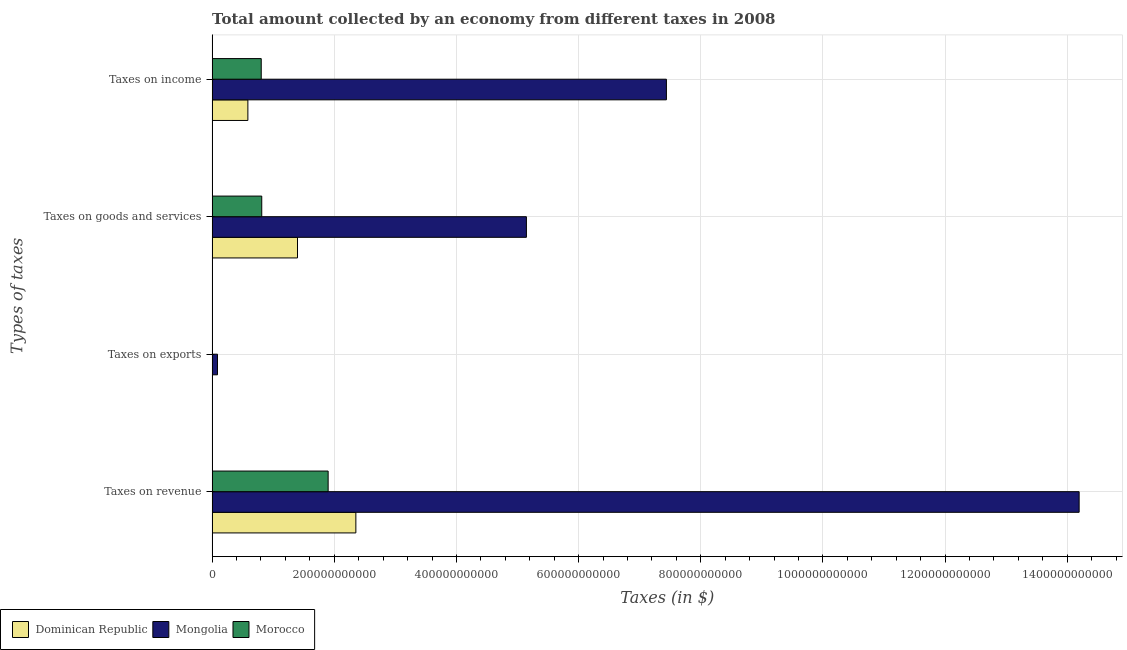How many different coloured bars are there?
Your response must be concise. 3. How many groups of bars are there?
Make the answer very short. 4. Are the number of bars per tick equal to the number of legend labels?
Your response must be concise. Yes. Are the number of bars on each tick of the Y-axis equal?
Offer a terse response. Yes. How many bars are there on the 2nd tick from the top?
Keep it short and to the point. 3. How many bars are there on the 3rd tick from the bottom?
Offer a terse response. 3. What is the label of the 2nd group of bars from the top?
Give a very brief answer. Taxes on goods and services. What is the amount collected as tax on exports in Mongolia?
Your answer should be very brief. 8.78e+09. Across all countries, what is the maximum amount collected as tax on exports?
Provide a short and direct response. 8.78e+09. Across all countries, what is the minimum amount collected as tax on goods?
Provide a succinct answer. 8.12e+1. In which country was the amount collected as tax on income maximum?
Offer a very short reply. Mongolia. In which country was the amount collected as tax on goods minimum?
Provide a short and direct response. Morocco. What is the total amount collected as tax on revenue in the graph?
Your response must be concise. 1.84e+12. What is the difference between the amount collected as tax on revenue in Dominican Republic and that in Mongolia?
Give a very brief answer. -1.18e+12. What is the difference between the amount collected as tax on revenue in Dominican Republic and the amount collected as tax on income in Mongolia?
Make the answer very short. -5.08e+11. What is the average amount collected as tax on exports per country?
Provide a short and direct response. 2.99e+09. What is the difference between the amount collected as tax on goods and amount collected as tax on exports in Mongolia?
Offer a terse response. 5.06e+11. In how many countries, is the amount collected as tax on income greater than 1120000000000 $?
Keep it short and to the point. 0. What is the ratio of the amount collected as tax on exports in Morocco to that in Dominican Republic?
Provide a short and direct response. 0.48. Is the amount collected as tax on income in Dominican Republic less than that in Mongolia?
Ensure brevity in your answer.  Yes. What is the difference between the highest and the second highest amount collected as tax on income?
Offer a very short reply. 6.63e+11. What is the difference between the highest and the lowest amount collected as tax on income?
Offer a very short reply. 6.85e+11. Is the sum of the amount collected as tax on exports in Dominican Republic and Morocco greater than the maximum amount collected as tax on income across all countries?
Offer a very short reply. No. What does the 3rd bar from the top in Taxes on goods and services represents?
Your response must be concise. Dominican Republic. What does the 1st bar from the bottom in Taxes on exports represents?
Offer a terse response. Dominican Republic. Is it the case that in every country, the sum of the amount collected as tax on revenue and amount collected as tax on exports is greater than the amount collected as tax on goods?
Make the answer very short. Yes. How many bars are there?
Your response must be concise. 12. Are all the bars in the graph horizontal?
Keep it short and to the point. Yes. What is the difference between two consecutive major ticks on the X-axis?
Your response must be concise. 2.00e+11. Are the values on the major ticks of X-axis written in scientific E-notation?
Give a very brief answer. No. Does the graph contain any zero values?
Provide a succinct answer. No. Does the graph contain grids?
Your answer should be compact. Yes. How many legend labels are there?
Provide a short and direct response. 3. What is the title of the graph?
Give a very brief answer. Total amount collected by an economy from different taxes in 2008. Does "Switzerland" appear as one of the legend labels in the graph?
Provide a succinct answer. No. What is the label or title of the X-axis?
Provide a short and direct response. Taxes (in $). What is the label or title of the Y-axis?
Keep it short and to the point. Types of taxes. What is the Taxes (in $) of Dominican Republic in Taxes on revenue?
Your response must be concise. 2.35e+11. What is the Taxes (in $) in Mongolia in Taxes on revenue?
Offer a terse response. 1.42e+12. What is the Taxes (in $) of Morocco in Taxes on revenue?
Provide a succinct answer. 1.90e+11. What is the Taxes (in $) of Dominican Republic in Taxes on exports?
Keep it short and to the point. 1.28e+08. What is the Taxes (in $) of Mongolia in Taxes on exports?
Provide a short and direct response. 8.78e+09. What is the Taxes (in $) of Morocco in Taxes on exports?
Your answer should be compact. 6.21e+07. What is the Taxes (in $) in Dominican Republic in Taxes on goods and services?
Keep it short and to the point. 1.40e+11. What is the Taxes (in $) of Mongolia in Taxes on goods and services?
Keep it short and to the point. 5.15e+11. What is the Taxes (in $) in Morocco in Taxes on goods and services?
Make the answer very short. 8.12e+1. What is the Taxes (in $) in Dominican Republic in Taxes on income?
Give a very brief answer. 5.85e+1. What is the Taxes (in $) in Mongolia in Taxes on income?
Keep it short and to the point. 7.44e+11. What is the Taxes (in $) of Morocco in Taxes on income?
Offer a very short reply. 8.04e+1. Across all Types of taxes, what is the maximum Taxes (in $) in Dominican Republic?
Your answer should be very brief. 2.35e+11. Across all Types of taxes, what is the maximum Taxes (in $) in Mongolia?
Your answer should be very brief. 1.42e+12. Across all Types of taxes, what is the maximum Taxes (in $) in Morocco?
Provide a short and direct response. 1.90e+11. Across all Types of taxes, what is the minimum Taxes (in $) of Dominican Republic?
Keep it short and to the point. 1.28e+08. Across all Types of taxes, what is the minimum Taxes (in $) in Mongolia?
Offer a very short reply. 8.78e+09. Across all Types of taxes, what is the minimum Taxes (in $) of Morocco?
Provide a succinct answer. 6.21e+07. What is the total Taxes (in $) of Dominican Republic in the graph?
Offer a very short reply. 4.34e+11. What is the total Taxes (in $) of Mongolia in the graph?
Your answer should be compact. 2.69e+12. What is the total Taxes (in $) of Morocco in the graph?
Ensure brevity in your answer.  3.52e+11. What is the difference between the Taxes (in $) in Dominican Republic in Taxes on revenue and that in Taxes on exports?
Your response must be concise. 2.35e+11. What is the difference between the Taxes (in $) in Mongolia in Taxes on revenue and that in Taxes on exports?
Provide a succinct answer. 1.41e+12. What is the difference between the Taxes (in $) in Morocco in Taxes on revenue and that in Taxes on exports?
Provide a succinct answer. 1.90e+11. What is the difference between the Taxes (in $) in Dominican Republic in Taxes on revenue and that in Taxes on goods and services?
Keep it short and to the point. 9.55e+1. What is the difference between the Taxes (in $) in Mongolia in Taxes on revenue and that in Taxes on goods and services?
Your answer should be compact. 9.05e+11. What is the difference between the Taxes (in $) of Morocco in Taxes on revenue and that in Taxes on goods and services?
Provide a succinct answer. 1.09e+11. What is the difference between the Taxes (in $) of Dominican Republic in Taxes on revenue and that in Taxes on income?
Provide a short and direct response. 1.77e+11. What is the difference between the Taxes (in $) in Mongolia in Taxes on revenue and that in Taxes on income?
Keep it short and to the point. 6.76e+11. What is the difference between the Taxes (in $) in Morocco in Taxes on revenue and that in Taxes on income?
Give a very brief answer. 1.10e+11. What is the difference between the Taxes (in $) of Dominican Republic in Taxes on exports and that in Taxes on goods and services?
Make the answer very short. -1.40e+11. What is the difference between the Taxes (in $) in Mongolia in Taxes on exports and that in Taxes on goods and services?
Give a very brief answer. -5.06e+11. What is the difference between the Taxes (in $) of Morocco in Taxes on exports and that in Taxes on goods and services?
Your response must be concise. -8.12e+1. What is the difference between the Taxes (in $) in Dominican Republic in Taxes on exports and that in Taxes on income?
Make the answer very short. -5.84e+1. What is the difference between the Taxes (in $) in Mongolia in Taxes on exports and that in Taxes on income?
Make the answer very short. -7.35e+11. What is the difference between the Taxes (in $) in Morocco in Taxes on exports and that in Taxes on income?
Keep it short and to the point. -8.03e+1. What is the difference between the Taxes (in $) in Dominican Republic in Taxes on goods and services and that in Taxes on income?
Offer a very short reply. 8.12e+1. What is the difference between the Taxes (in $) in Mongolia in Taxes on goods and services and that in Taxes on income?
Your response must be concise. -2.29e+11. What is the difference between the Taxes (in $) in Morocco in Taxes on goods and services and that in Taxes on income?
Your answer should be very brief. 8.37e+08. What is the difference between the Taxes (in $) in Dominican Republic in Taxes on revenue and the Taxes (in $) in Mongolia in Taxes on exports?
Give a very brief answer. 2.27e+11. What is the difference between the Taxes (in $) in Dominican Republic in Taxes on revenue and the Taxes (in $) in Morocco in Taxes on exports?
Your answer should be compact. 2.35e+11. What is the difference between the Taxes (in $) in Mongolia in Taxes on revenue and the Taxes (in $) in Morocco in Taxes on exports?
Offer a terse response. 1.42e+12. What is the difference between the Taxes (in $) of Dominican Republic in Taxes on revenue and the Taxes (in $) of Mongolia in Taxes on goods and services?
Your answer should be very brief. -2.79e+11. What is the difference between the Taxes (in $) in Dominican Republic in Taxes on revenue and the Taxes (in $) in Morocco in Taxes on goods and services?
Your response must be concise. 1.54e+11. What is the difference between the Taxes (in $) in Mongolia in Taxes on revenue and the Taxes (in $) in Morocco in Taxes on goods and services?
Make the answer very short. 1.34e+12. What is the difference between the Taxes (in $) of Dominican Republic in Taxes on revenue and the Taxes (in $) of Mongolia in Taxes on income?
Your answer should be compact. -5.08e+11. What is the difference between the Taxes (in $) in Dominican Republic in Taxes on revenue and the Taxes (in $) in Morocco in Taxes on income?
Offer a terse response. 1.55e+11. What is the difference between the Taxes (in $) of Mongolia in Taxes on revenue and the Taxes (in $) of Morocco in Taxes on income?
Keep it short and to the point. 1.34e+12. What is the difference between the Taxes (in $) in Dominican Republic in Taxes on exports and the Taxes (in $) in Mongolia in Taxes on goods and services?
Make the answer very short. -5.14e+11. What is the difference between the Taxes (in $) of Dominican Republic in Taxes on exports and the Taxes (in $) of Morocco in Taxes on goods and services?
Offer a very short reply. -8.11e+1. What is the difference between the Taxes (in $) in Mongolia in Taxes on exports and the Taxes (in $) in Morocco in Taxes on goods and services?
Your answer should be very brief. -7.25e+1. What is the difference between the Taxes (in $) of Dominican Republic in Taxes on exports and the Taxes (in $) of Mongolia in Taxes on income?
Keep it short and to the point. -7.44e+11. What is the difference between the Taxes (in $) of Dominican Republic in Taxes on exports and the Taxes (in $) of Morocco in Taxes on income?
Your answer should be very brief. -8.03e+1. What is the difference between the Taxes (in $) of Mongolia in Taxes on exports and the Taxes (in $) of Morocco in Taxes on income?
Provide a short and direct response. -7.16e+1. What is the difference between the Taxes (in $) of Dominican Republic in Taxes on goods and services and the Taxes (in $) of Mongolia in Taxes on income?
Provide a short and direct response. -6.04e+11. What is the difference between the Taxes (in $) of Dominican Republic in Taxes on goods and services and the Taxes (in $) of Morocco in Taxes on income?
Keep it short and to the point. 5.94e+1. What is the difference between the Taxes (in $) of Mongolia in Taxes on goods and services and the Taxes (in $) of Morocco in Taxes on income?
Provide a succinct answer. 4.34e+11. What is the average Taxes (in $) in Dominican Republic per Types of taxes?
Ensure brevity in your answer.  1.08e+11. What is the average Taxes (in $) of Mongolia per Types of taxes?
Make the answer very short. 6.72e+11. What is the average Taxes (in $) in Morocco per Types of taxes?
Give a very brief answer. 8.79e+1. What is the difference between the Taxes (in $) in Dominican Republic and Taxes (in $) in Mongolia in Taxes on revenue?
Ensure brevity in your answer.  -1.18e+12. What is the difference between the Taxes (in $) of Dominican Republic and Taxes (in $) of Morocco in Taxes on revenue?
Give a very brief answer. 4.54e+1. What is the difference between the Taxes (in $) in Mongolia and Taxes (in $) in Morocco in Taxes on revenue?
Provide a succinct answer. 1.23e+12. What is the difference between the Taxes (in $) in Dominican Republic and Taxes (in $) in Mongolia in Taxes on exports?
Keep it short and to the point. -8.65e+09. What is the difference between the Taxes (in $) in Dominican Republic and Taxes (in $) in Morocco in Taxes on exports?
Provide a succinct answer. 6.60e+07. What is the difference between the Taxes (in $) in Mongolia and Taxes (in $) in Morocco in Taxes on exports?
Make the answer very short. 8.72e+09. What is the difference between the Taxes (in $) in Dominican Republic and Taxes (in $) in Mongolia in Taxes on goods and services?
Provide a succinct answer. -3.75e+11. What is the difference between the Taxes (in $) in Dominican Republic and Taxes (in $) in Morocco in Taxes on goods and services?
Provide a succinct answer. 5.85e+1. What is the difference between the Taxes (in $) in Mongolia and Taxes (in $) in Morocco in Taxes on goods and services?
Give a very brief answer. 4.33e+11. What is the difference between the Taxes (in $) in Dominican Republic and Taxes (in $) in Mongolia in Taxes on income?
Provide a succinct answer. -6.85e+11. What is the difference between the Taxes (in $) of Dominican Republic and Taxes (in $) of Morocco in Taxes on income?
Your answer should be compact. -2.19e+1. What is the difference between the Taxes (in $) in Mongolia and Taxes (in $) in Morocco in Taxes on income?
Provide a short and direct response. 6.63e+11. What is the ratio of the Taxes (in $) in Dominican Republic in Taxes on revenue to that in Taxes on exports?
Offer a very short reply. 1836.2. What is the ratio of the Taxes (in $) of Mongolia in Taxes on revenue to that in Taxes on exports?
Provide a succinct answer. 161.62. What is the ratio of the Taxes (in $) in Morocco in Taxes on revenue to that in Taxes on exports?
Your answer should be very brief. 3057.65. What is the ratio of the Taxes (in $) of Dominican Republic in Taxes on revenue to that in Taxes on goods and services?
Keep it short and to the point. 1.68. What is the ratio of the Taxes (in $) of Mongolia in Taxes on revenue to that in Taxes on goods and services?
Give a very brief answer. 2.76. What is the ratio of the Taxes (in $) of Morocco in Taxes on revenue to that in Taxes on goods and services?
Your answer should be compact. 2.34. What is the ratio of the Taxes (in $) in Dominican Republic in Taxes on revenue to that in Taxes on income?
Make the answer very short. 4.02. What is the ratio of the Taxes (in $) of Mongolia in Taxes on revenue to that in Taxes on income?
Offer a terse response. 1.91. What is the ratio of the Taxes (in $) in Morocco in Taxes on revenue to that in Taxes on income?
Ensure brevity in your answer.  2.36. What is the ratio of the Taxes (in $) in Dominican Republic in Taxes on exports to that in Taxes on goods and services?
Your answer should be compact. 0. What is the ratio of the Taxes (in $) of Mongolia in Taxes on exports to that in Taxes on goods and services?
Make the answer very short. 0.02. What is the ratio of the Taxes (in $) in Morocco in Taxes on exports to that in Taxes on goods and services?
Offer a terse response. 0. What is the ratio of the Taxes (in $) of Dominican Republic in Taxes on exports to that in Taxes on income?
Your answer should be compact. 0. What is the ratio of the Taxes (in $) of Mongolia in Taxes on exports to that in Taxes on income?
Offer a very short reply. 0.01. What is the ratio of the Taxes (in $) in Morocco in Taxes on exports to that in Taxes on income?
Provide a short and direct response. 0. What is the ratio of the Taxes (in $) in Dominican Republic in Taxes on goods and services to that in Taxes on income?
Offer a terse response. 2.39. What is the ratio of the Taxes (in $) of Mongolia in Taxes on goods and services to that in Taxes on income?
Ensure brevity in your answer.  0.69. What is the ratio of the Taxes (in $) in Morocco in Taxes on goods and services to that in Taxes on income?
Give a very brief answer. 1.01. What is the difference between the highest and the second highest Taxes (in $) in Dominican Republic?
Provide a short and direct response. 9.55e+1. What is the difference between the highest and the second highest Taxes (in $) of Mongolia?
Make the answer very short. 6.76e+11. What is the difference between the highest and the second highest Taxes (in $) of Morocco?
Offer a terse response. 1.09e+11. What is the difference between the highest and the lowest Taxes (in $) in Dominican Republic?
Make the answer very short. 2.35e+11. What is the difference between the highest and the lowest Taxes (in $) in Mongolia?
Your response must be concise. 1.41e+12. What is the difference between the highest and the lowest Taxes (in $) of Morocco?
Your answer should be compact. 1.90e+11. 